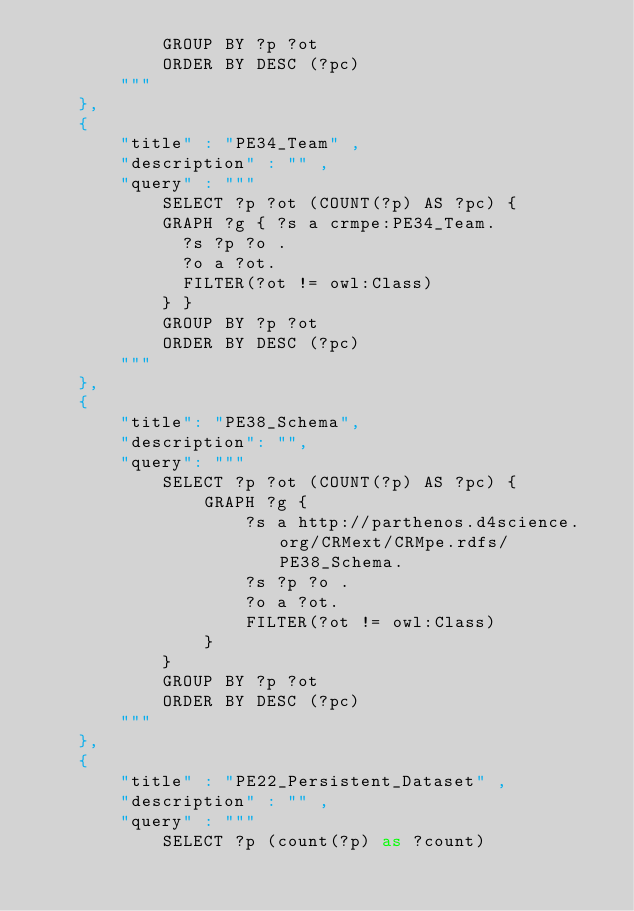Convert code to text. <code><loc_0><loc_0><loc_500><loc_500><_Python_>			GROUP BY ?p ?ot
			ORDER BY DESC (?pc)
        """
    },
    {    
        "title" : "PE34_Team" , 
        "description" : "" , 
        "query" : """
			SELECT ?p ?ot (COUNT(?p) AS ?pc) {
			GRAPH ?g { ?s a crmpe:PE34_Team.
			  ?s ?p ?o .
			  ?o a ?ot.
			  FILTER(?ot != owl:Class)
			} }
			GROUP BY ?p ?ot
			ORDER BY DESC (?pc)
        """
    }, 
    {
        "title": "PE38_Schema",
        "description": "",
        "query": """
			SELECT ?p ?ot (COUNT(?p) AS ?pc) {
                GRAPH ?g { 
                    ?s a http://parthenos.d4science.org/CRMext/CRMpe.rdfs/PE38_Schema.
                    ?s ?p ?o .
                    ?o a ?ot.
                    FILTER(?ot != owl:Class)
                } 
			}
			GROUP BY ?p ?ot
			ORDER BY DESC (?pc)
        """
    },
    {    
        "title" : "PE22_Persistent_Dataset" , 
        "description" : "" , 
        "query" : """
			SELECT ?p (count(?p) as ?count) </code> 